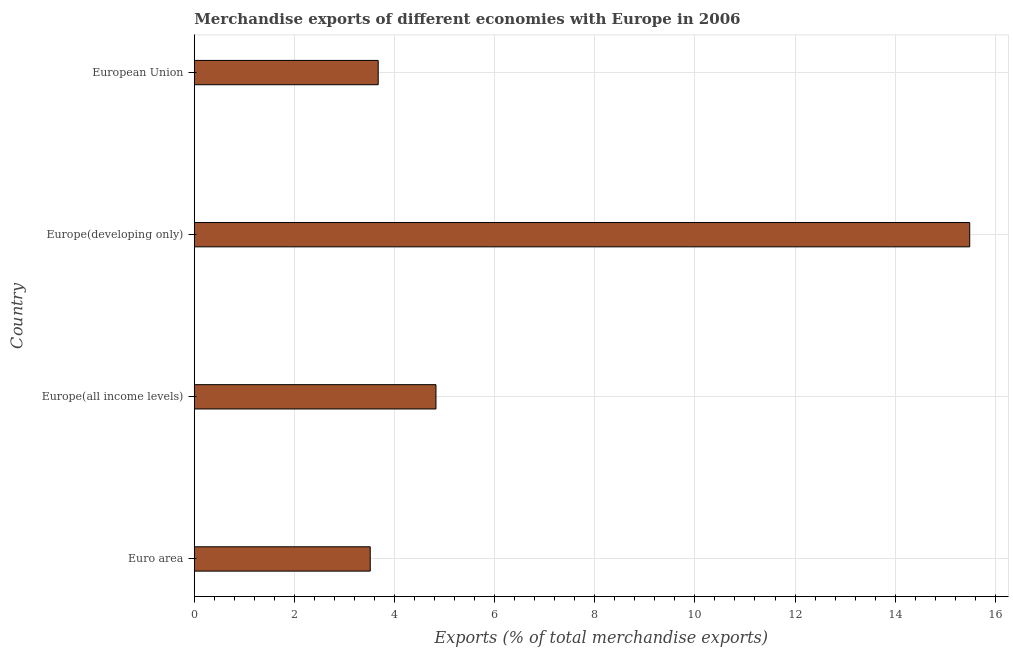Does the graph contain any zero values?
Provide a succinct answer. No. Does the graph contain grids?
Keep it short and to the point. Yes. What is the title of the graph?
Give a very brief answer. Merchandise exports of different economies with Europe in 2006. What is the label or title of the X-axis?
Your answer should be compact. Exports (% of total merchandise exports). What is the label or title of the Y-axis?
Offer a terse response. Country. What is the merchandise exports in Europe(all income levels)?
Give a very brief answer. 4.83. Across all countries, what is the maximum merchandise exports?
Provide a succinct answer. 15.49. Across all countries, what is the minimum merchandise exports?
Offer a terse response. 3.51. In which country was the merchandise exports maximum?
Give a very brief answer. Europe(developing only). In which country was the merchandise exports minimum?
Your response must be concise. Euro area. What is the sum of the merchandise exports?
Your answer should be compact. 27.51. What is the difference between the merchandise exports in Europe(developing only) and European Union?
Your answer should be compact. 11.81. What is the average merchandise exports per country?
Keep it short and to the point. 6.88. What is the median merchandise exports?
Offer a very short reply. 4.25. What is the ratio of the merchandise exports in Euro area to that in Europe(all income levels)?
Your answer should be very brief. 0.73. What is the difference between the highest and the second highest merchandise exports?
Provide a short and direct response. 10.66. What is the difference between the highest and the lowest merchandise exports?
Your answer should be compact. 11.97. How many bars are there?
Provide a succinct answer. 4. Are all the bars in the graph horizontal?
Offer a very short reply. Yes. How many countries are there in the graph?
Offer a terse response. 4. Are the values on the major ticks of X-axis written in scientific E-notation?
Offer a very short reply. No. What is the Exports (% of total merchandise exports) of Euro area?
Make the answer very short. 3.51. What is the Exports (% of total merchandise exports) of Europe(all income levels)?
Make the answer very short. 4.83. What is the Exports (% of total merchandise exports) in Europe(developing only)?
Provide a short and direct response. 15.49. What is the Exports (% of total merchandise exports) in European Union?
Ensure brevity in your answer.  3.67. What is the difference between the Exports (% of total merchandise exports) in Euro area and Europe(all income levels)?
Give a very brief answer. -1.31. What is the difference between the Exports (% of total merchandise exports) in Euro area and Europe(developing only)?
Provide a short and direct response. -11.97. What is the difference between the Exports (% of total merchandise exports) in Euro area and European Union?
Your answer should be very brief. -0.16. What is the difference between the Exports (% of total merchandise exports) in Europe(all income levels) and Europe(developing only)?
Your answer should be very brief. -10.66. What is the difference between the Exports (% of total merchandise exports) in Europe(all income levels) and European Union?
Provide a succinct answer. 1.15. What is the difference between the Exports (% of total merchandise exports) in Europe(developing only) and European Union?
Offer a very short reply. 11.81. What is the ratio of the Exports (% of total merchandise exports) in Euro area to that in Europe(all income levels)?
Make the answer very short. 0.73. What is the ratio of the Exports (% of total merchandise exports) in Euro area to that in Europe(developing only)?
Offer a terse response. 0.23. What is the ratio of the Exports (% of total merchandise exports) in Euro area to that in European Union?
Provide a short and direct response. 0.96. What is the ratio of the Exports (% of total merchandise exports) in Europe(all income levels) to that in Europe(developing only)?
Your answer should be compact. 0.31. What is the ratio of the Exports (% of total merchandise exports) in Europe(all income levels) to that in European Union?
Offer a very short reply. 1.31. What is the ratio of the Exports (% of total merchandise exports) in Europe(developing only) to that in European Union?
Make the answer very short. 4.22. 